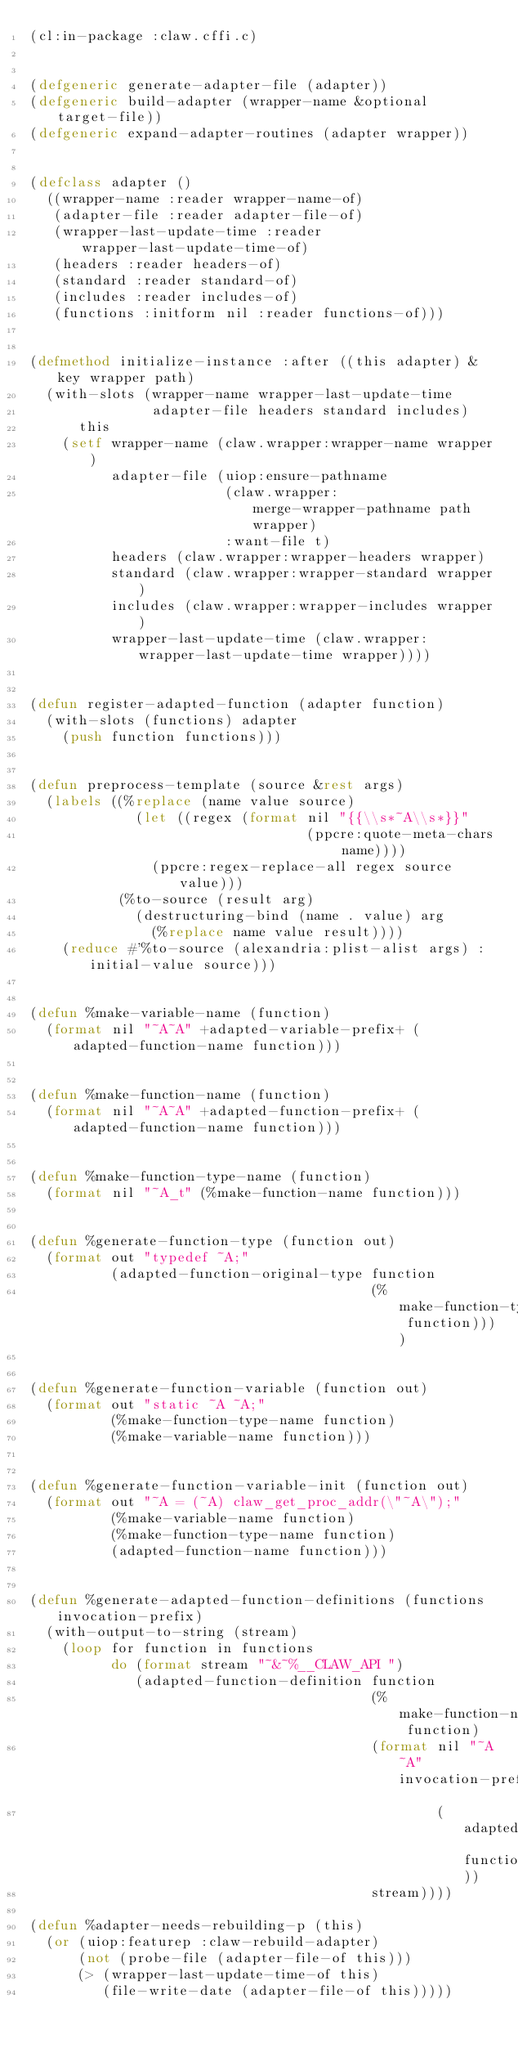<code> <loc_0><loc_0><loc_500><loc_500><_Lisp_>(cl:in-package :claw.cffi.c)


(defgeneric generate-adapter-file (adapter))
(defgeneric build-adapter (wrapper-name &optional target-file))
(defgeneric expand-adapter-routines (adapter wrapper))


(defclass adapter ()
  ((wrapper-name :reader wrapper-name-of)
   (adapter-file :reader adapter-file-of)
   (wrapper-last-update-time :reader wrapper-last-update-time-of)
   (headers :reader headers-of)
   (standard :reader standard-of)
   (includes :reader includes-of)
   (functions :initform nil :reader functions-of)))


(defmethod initialize-instance :after ((this adapter) &key wrapper path)
  (with-slots (wrapper-name wrapper-last-update-time
               adapter-file headers standard includes)
      this
    (setf wrapper-name (claw.wrapper:wrapper-name wrapper)
          adapter-file (uiop:ensure-pathname
                        (claw.wrapper:merge-wrapper-pathname path wrapper)
                        :want-file t)
          headers (claw.wrapper:wrapper-headers wrapper)
          standard (claw.wrapper:wrapper-standard wrapper)
          includes (claw.wrapper:wrapper-includes wrapper)
          wrapper-last-update-time (claw.wrapper:wrapper-last-update-time wrapper))))


(defun register-adapted-function (adapter function)
  (with-slots (functions) adapter
    (push function functions)))


(defun preprocess-template (source &rest args)
  (labels ((%replace (name value source)
             (let ((regex (format nil "{{\\s*~A\\s*}}"
                                  (ppcre:quote-meta-chars name))))
               (ppcre:regex-replace-all regex source value)))
           (%to-source (result arg)
             (destructuring-bind (name . value) arg
               (%replace name value result))))
    (reduce #'%to-source (alexandria:plist-alist args) :initial-value source)))


(defun %make-variable-name (function)
  (format nil "~A~A" +adapted-variable-prefix+ (adapted-function-name function)))


(defun %make-function-name (function)
  (format nil "~A~A" +adapted-function-prefix+ (adapted-function-name function)))


(defun %make-function-type-name (function)
  (format nil "~A_t" (%make-function-name function)))


(defun %generate-function-type (function out)
  (format out "typedef ~A;"
          (adapted-function-original-type function
                                          (%make-function-type-name function))))


(defun %generate-function-variable (function out)
  (format out "static ~A ~A;"
          (%make-function-type-name function)
          (%make-variable-name function)))


(defun %generate-function-variable-init (function out)
  (format out "~A = (~A) claw_get_proc_addr(\"~A\");"
          (%make-variable-name function)
          (%make-function-type-name function)
          (adapted-function-name function)))


(defun %generate-adapted-function-definitions (functions invocation-prefix)
  (with-output-to-string (stream)
    (loop for function in functions
          do (format stream "~&~%__CLAW_API ")
             (adapted-function-definition function
                                          (%make-function-name function)
                                          (format nil "~A~A" invocation-prefix
                                                  (adapted-function-name function))
                                          stream))))

(defun %adapter-needs-rebuilding-p (this)
  (or (uiop:featurep :claw-rebuild-adapter)
      (not (probe-file (adapter-file-of this)))
      (> (wrapper-last-update-time-of this)
         (file-write-date (adapter-file-of this)))))
</code> 